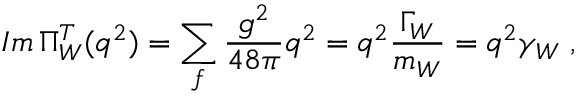Convert formula to latex. <formula><loc_0><loc_0><loc_500><loc_500>I m \, \Pi _ { W } ^ { T } ( q ^ { 2 } ) = \sum _ { f } { \frac { g ^ { 2 } } { 4 8 \pi } } q ^ { 2 } = q ^ { 2 } { \frac { \Gamma _ { W } } { m _ { W } } } = q ^ { 2 } \gamma _ { W } \, ,</formula> 